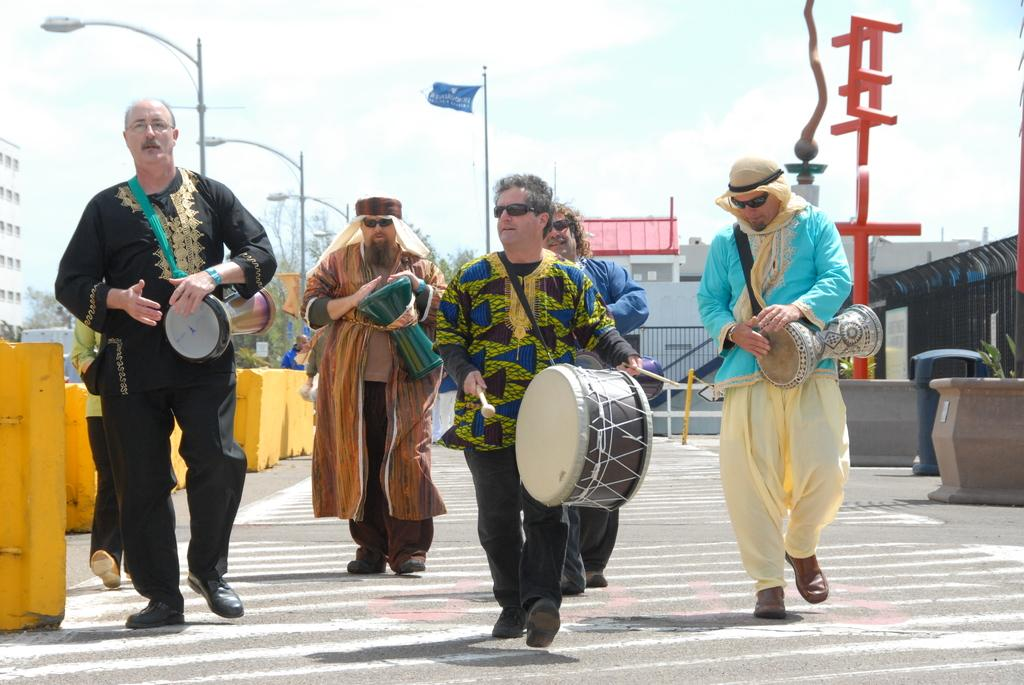How many people are in the image? There are five men in the image. What are the men doing in the image? The men are walking on a road and playing musical instruments. What can be seen in the background of the image? There is a light pole, a building, the sky, and a tree in the background of the image. What type of wood is being used to build the grade in the image? There is no wood or grade being built in the image; it features five men walking and playing musical instruments. 